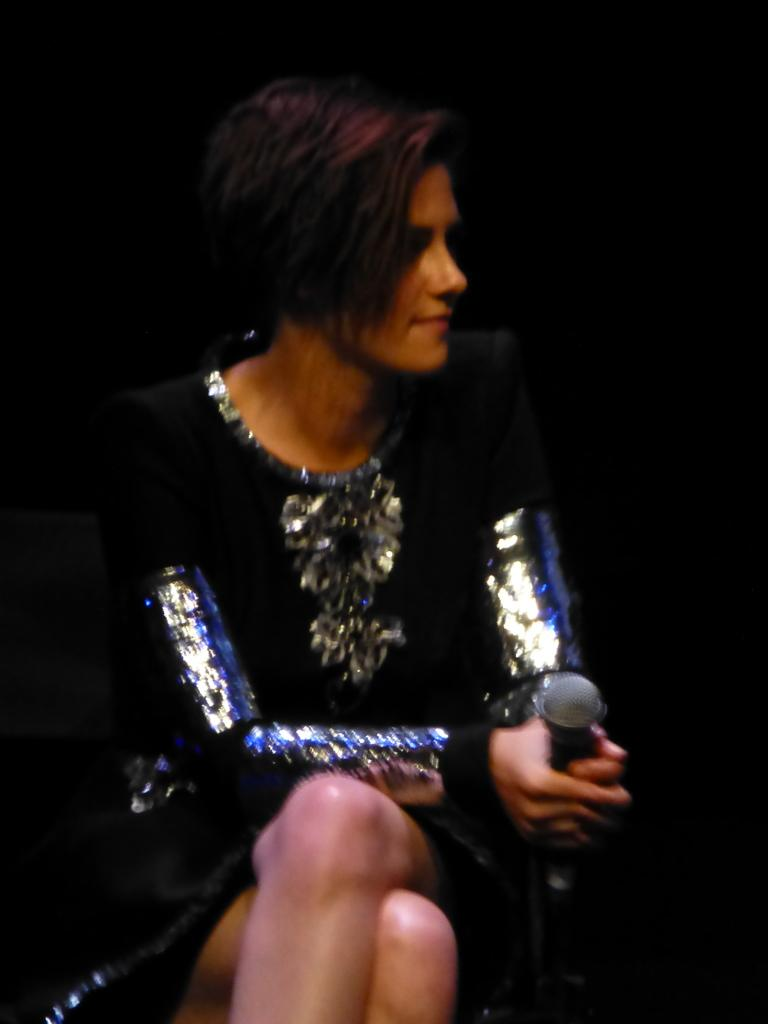What is the person in the image wearing? The person is wearing a dress in the image. Can you describe the colors of the dress? The dress has black, silver, and blue colors. What is the person holding in the image? The person is holding a mic. What color is the background of the image? The background of the image is black. How many teeth can be seen in the image? There are no teeth visible in the image, as it features a person wearing a dress and holding a mic against a black background. 